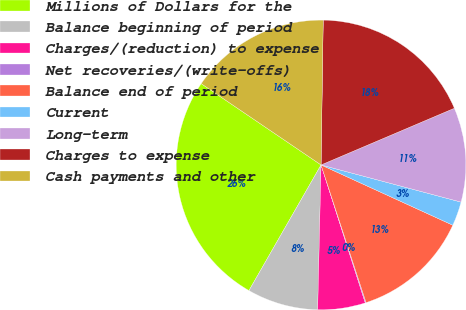<chart> <loc_0><loc_0><loc_500><loc_500><pie_chart><fcel>Millions of Dollars for the<fcel>Balance beginning of period<fcel>Charges/(reduction) to expense<fcel>Net recoveries/(write-offs)<fcel>Balance end of period<fcel>Current<fcel>Long-term<fcel>Charges to expense<fcel>Cash payments and other<nl><fcel>26.19%<fcel>7.92%<fcel>5.31%<fcel>0.09%<fcel>13.14%<fcel>2.7%<fcel>10.53%<fcel>18.36%<fcel>15.75%<nl></chart> 